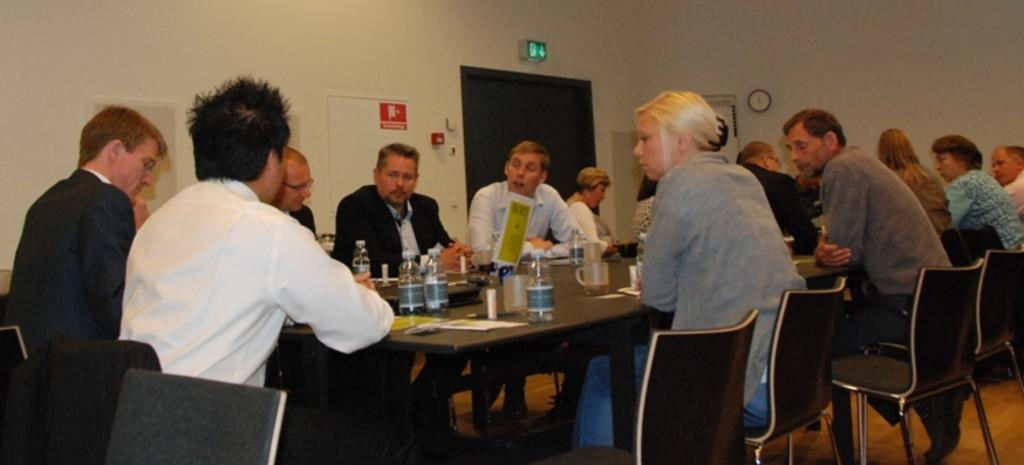How many people are in the image? There are several people in the image. What are the people doing in the image? The people are sitting at a table. What can be seen on the table besides the people? There are food items on the table. What is visible in the background of the image? There is an exit door in the background of the image. What type of skin can be seen on the people in the image? The image does not provide enough detail to determine the type of skin on the people. Where is the wilderness located in the image? There is no wilderness present in the image; it features people sitting at a table with food items. 